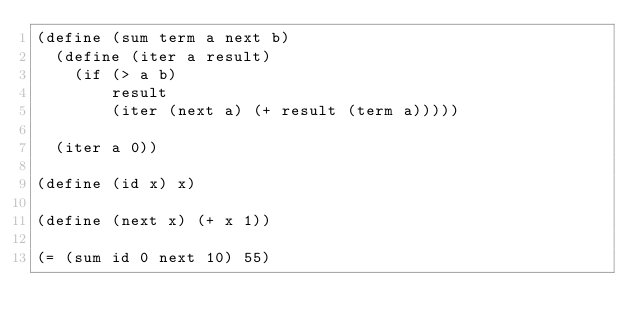Convert code to text. <code><loc_0><loc_0><loc_500><loc_500><_Scheme_>(define (sum term a next b)
  (define (iter a result)
    (if (> a b)
        result
        (iter (next a) (+ result (term a)))))

  (iter a 0))

(define (id x) x)

(define (next x) (+ x 1))

(= (sum id 0 next 10) 55)
</code> 